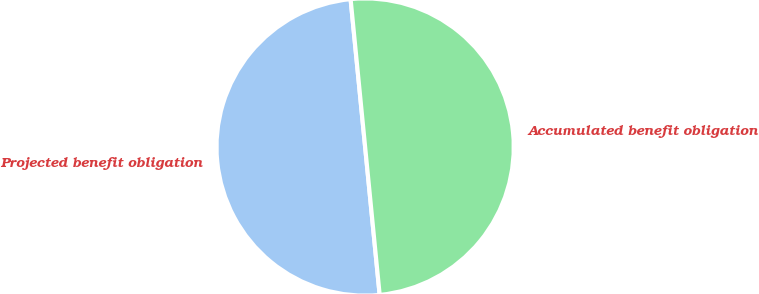<chart> <loc_0><loc_0><loc_500><loc_500><pie_chart><fcel>Projected benefit obligation<fcel>Accumulated benefit obligation<nl><fcel>50.0%<fcel>50.0%<nl></chart> 